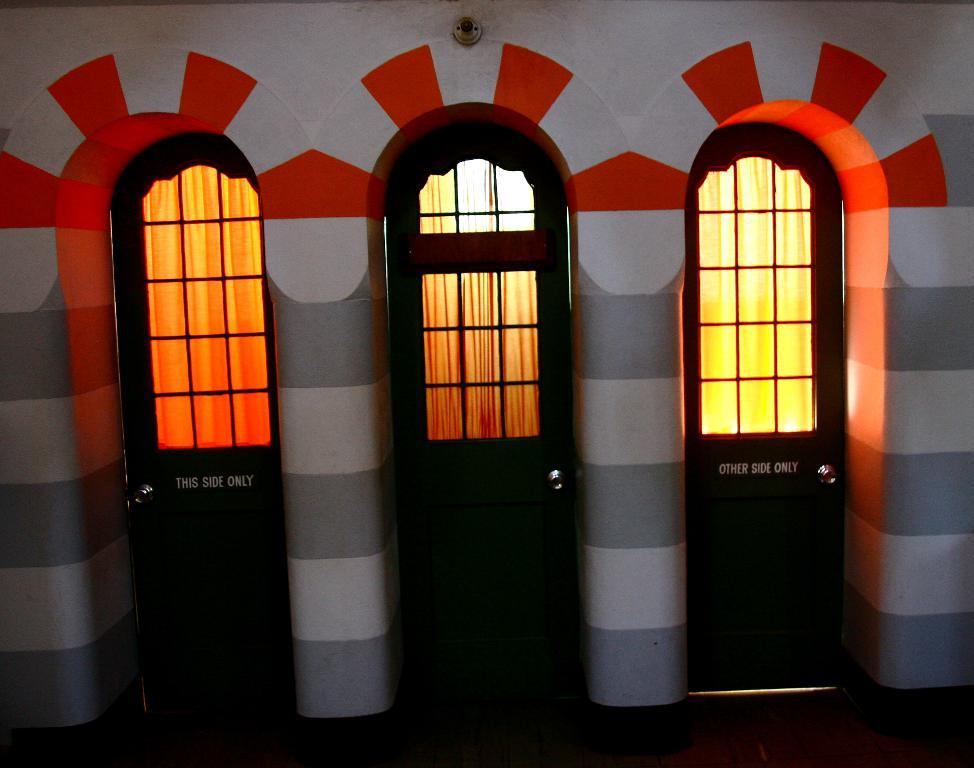How many doors can be seen in the image? There are three doors in the image. What is located at the top of the image? There is a light at the top of the image. What is behind the doors in the image? Clothes are visible behind the doors. What is on the right side of the image? There is a wall on the right side of the image. How many coats are hanging on the bikes in the image? There are no bikes or coats present in the image. What does the brother do in the image? There is no brother present in the image. 